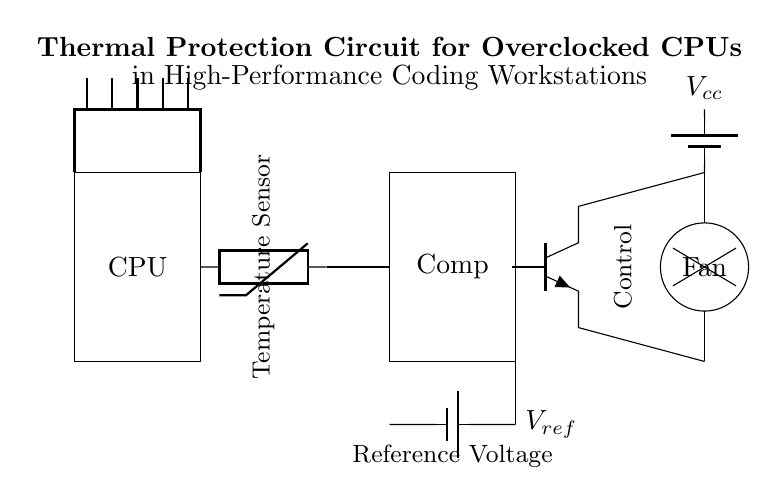What is the main component used for temperature sensing in this circuit? The temperature sensing is performed by the thermistor, which is clearly labeled in the circuit diagram. It connects the CPU to the comparator and measures the temperature.
Answer: thermistor What does the comparator compare against? The comparator compares the voltage from the thermistor with the reference voltage, which is provided by the battery labeled as Vref. It is essential for determining whether temperature conditions are safe or if cooling needs to be activated.
Answer: reference voltage What component is responsible for cooling in this circuit? The fan is the component responsible for cooling. It is shown in the circuit diagram as a circular shape and is connected to the output of the transistor, which activates it based on the comparator's output.
Answer: fan What is the role of the transistor in this circuit? The transistor acts as a control element, determining whether the fan should be turned on or off based on the output of the comparator. When the temperature exceeds the threshold, the transistor will allow current to flow to the fan.
Answer: control How does the reference voltage affect the operation of the circuit? The reference voltage sets a threshold that the voltage from the thermistor is compared against. If the thermistor's voltage exceeds this reference voltage, the comparator activates the transistor, which turns on the fan to cool the CPU.
Answer: sets threshold What is the purpose of the battery labeled Vcc in this circuit? The battery labeled Vcc provides the necessary voltage supply for the entire circuit, particularly for powering the fan and the transistor to control its operation.
Answer: power supply What happens if the temperature sensor detects an unsafe temperature? If the thermistor detects a temperature above the reference voltage, the comparator will signal the transistor to turn on, which activates the fan to cool down the CPU, protecting it from thermal damage.
Answer: activates fan 